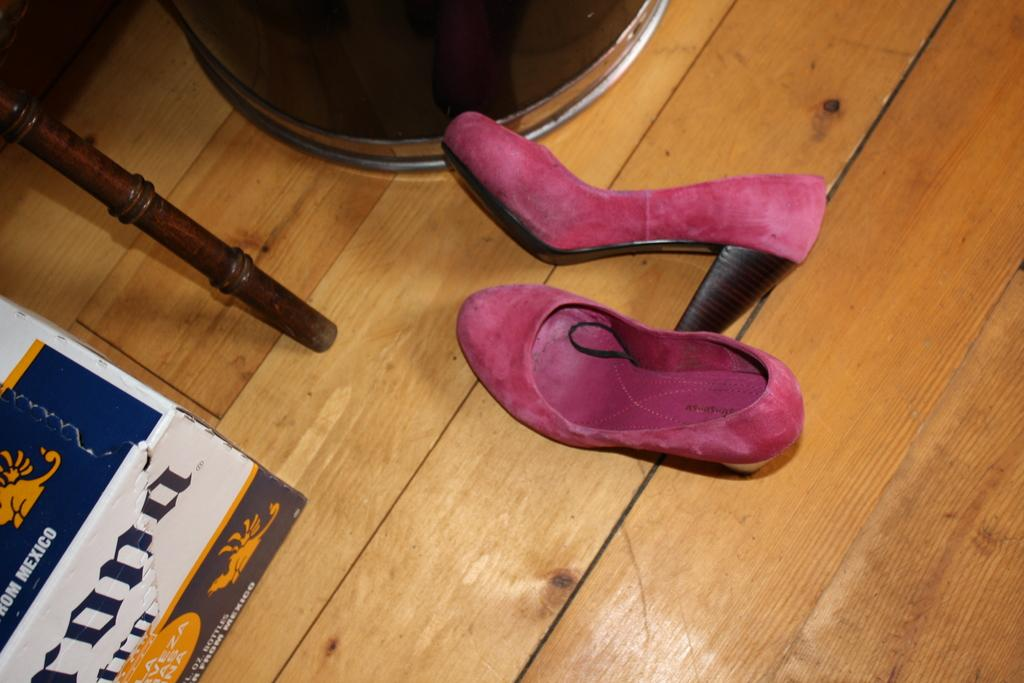What type of object is present on the wooden floor in the image? There is footwear on the wooden floor in the image. Can you describe the surface on which the footwear is placed? The footwear is on a wooden floor. What type of light is being used by the company in the image? There is no mention of a company or any type of light in the image; it only features footwear on a wooden floor. 